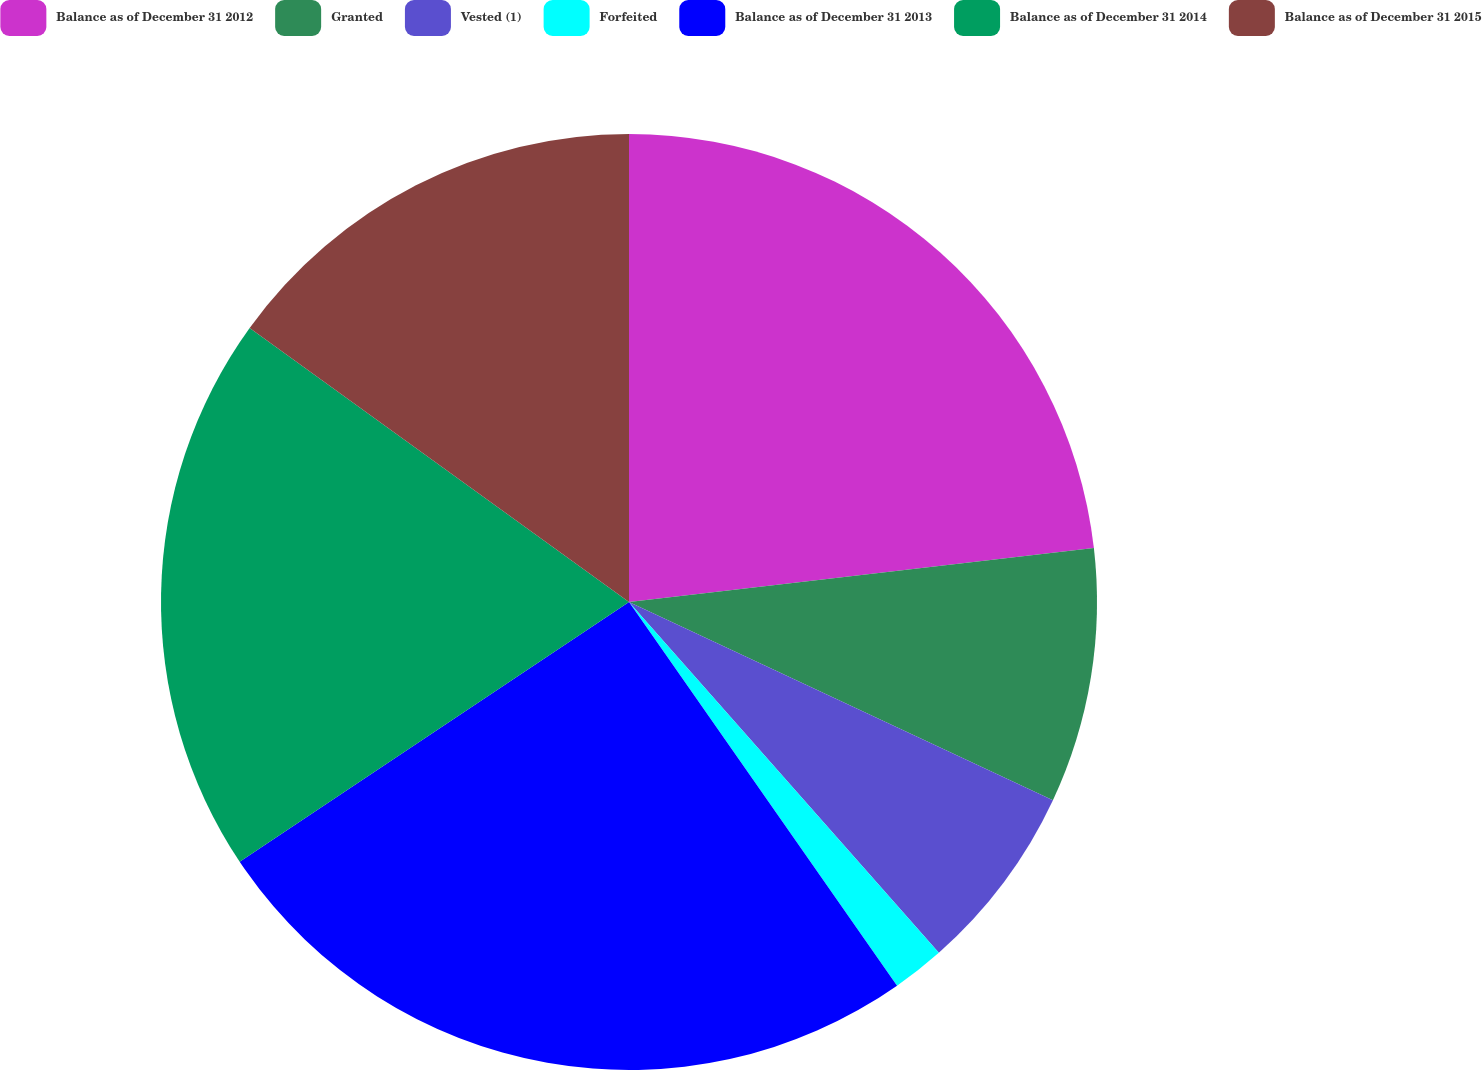Convert chart. <chart><loc_0><loc_0><loc_500><loc_500><pie_chart><fcel>Balance as of December 31 2012<fcel>Granted<fcel>Vested (1)<fcel>Forfeited<fcel>Balance as of December 31 2013<fcel>Balance as of December 31 2014<fcel>Balance as of December 31 2015<nl><fcel>23.16%<fcel>8.8%<fcel>6.52%<fcel>1.81%<fcel>25.34%<fcel>19.32%<fcel>15.04%<nl></chart> 